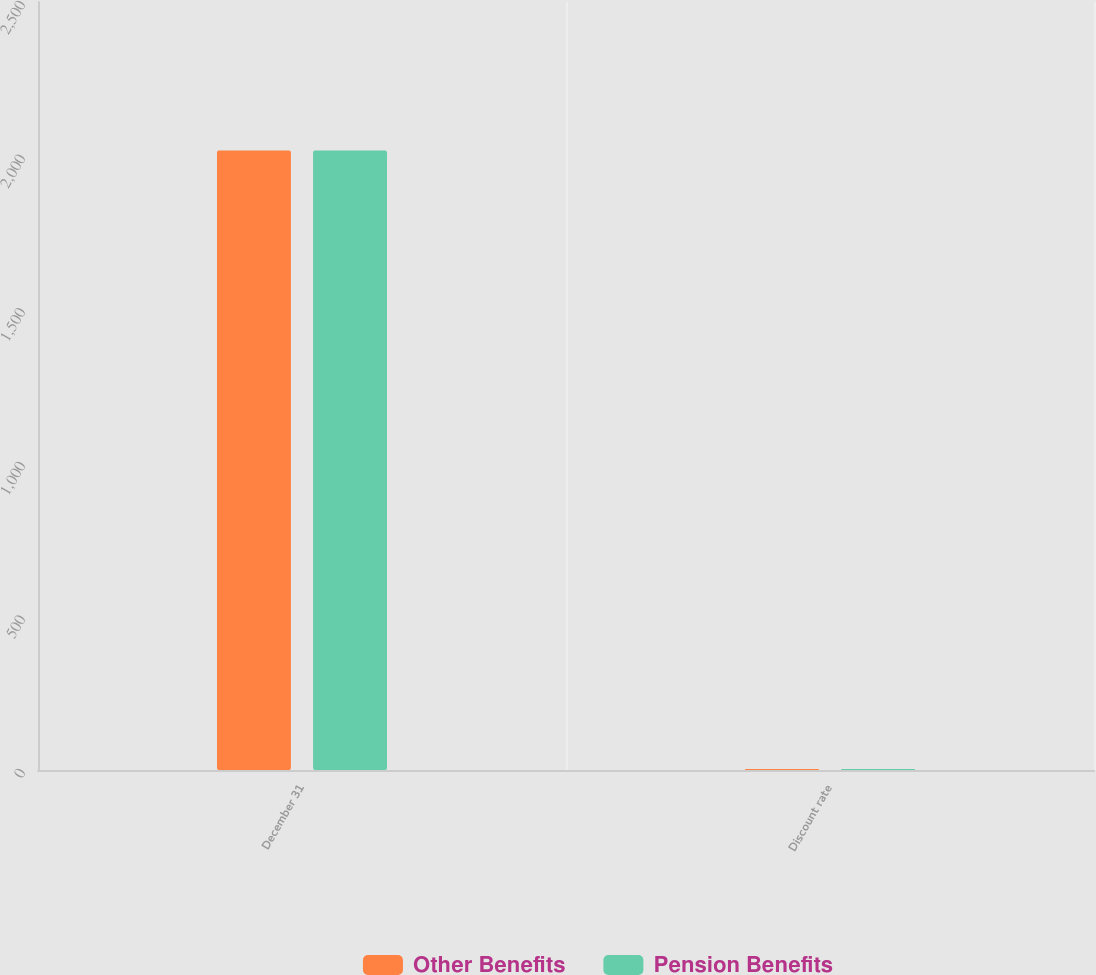<chart> <loc_0><loc_0><loc_500><loc_500><stacked_bar_chart><ecel><fcel>December 31<fcel>Discount rate<nl><fcel>Other Benefits<fcel>2017<fcel>3.5<nl><fcel>Pension Benefits<fcel>2017<fcel>3.5<nl></chart> 